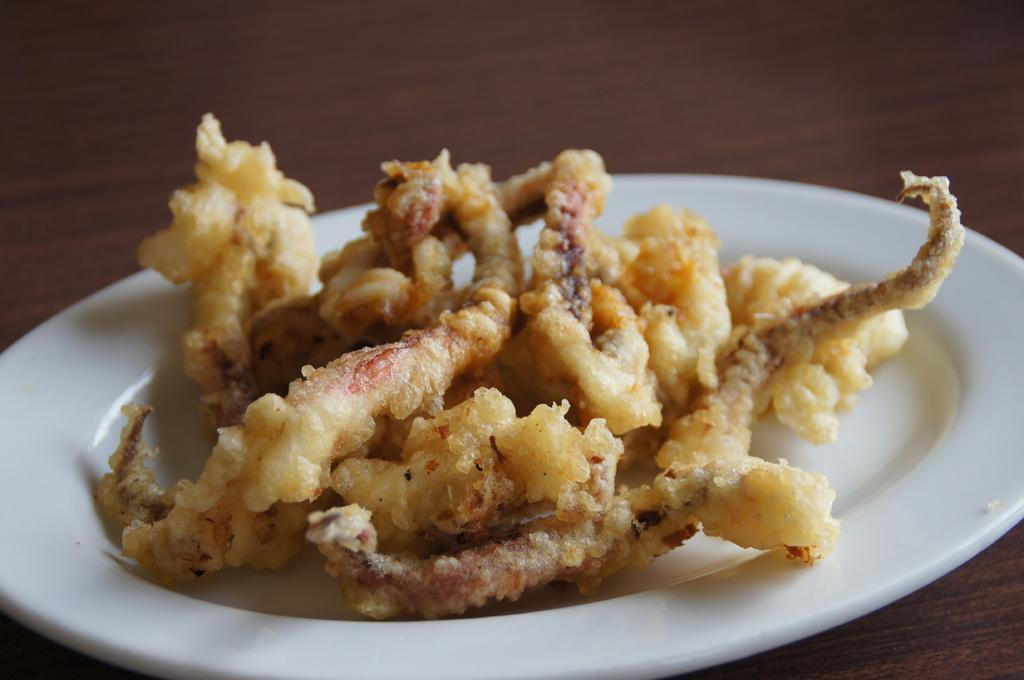What object is present on the table in the image? There is a plate in the image. What is on the plate? There is a food item on the plate. Where is the plate located? The plate is on a table. How many bananas are on the dime in the image? There are no bananas or dimes present in the image. What type of trucks can be seen driving through the food item on the plate? There are no trucks visible in the image. 